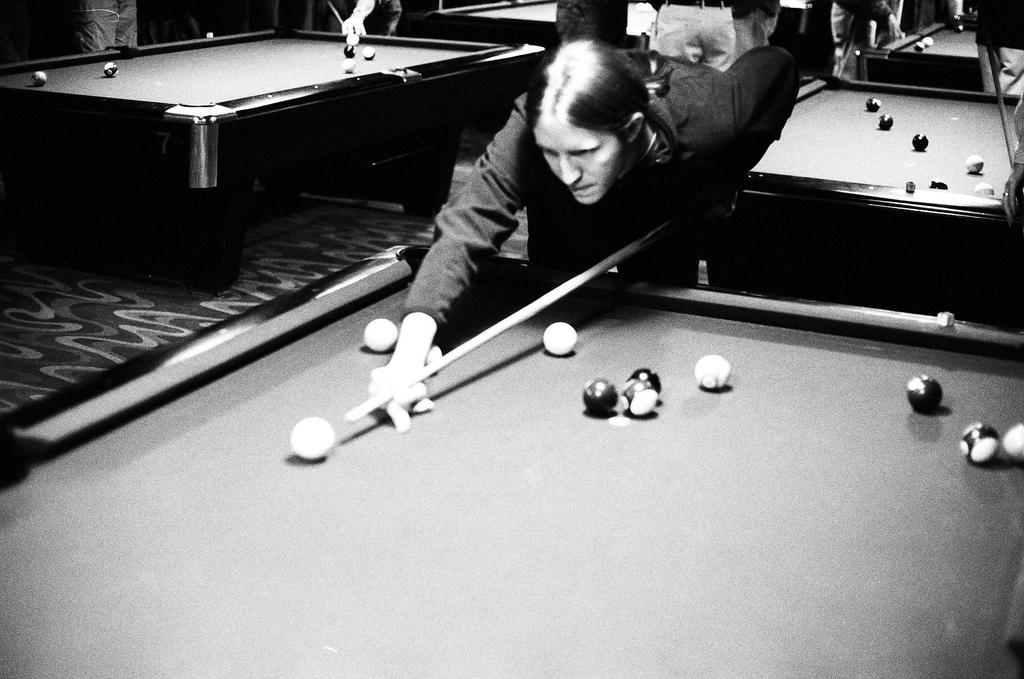Who is the main subject in the image? There is a woman in the image. What is the woman doing in the image? The woman is playing 8 ball pool. What is the setting for the activity in the image? There is a pool table in the image. What are the essential components for playing pool in the image? Pool balls and a pool stick are visible in the image. What type of fear can be seen on the woman's face in the image? There is no indication of fear on the woman's face in the image; she appears to be focused on playing pool. What color of paint is being used on the pool table in the image? There is no paint visible on the pool table in the image; it is made of a different material, such as wood or slate. 